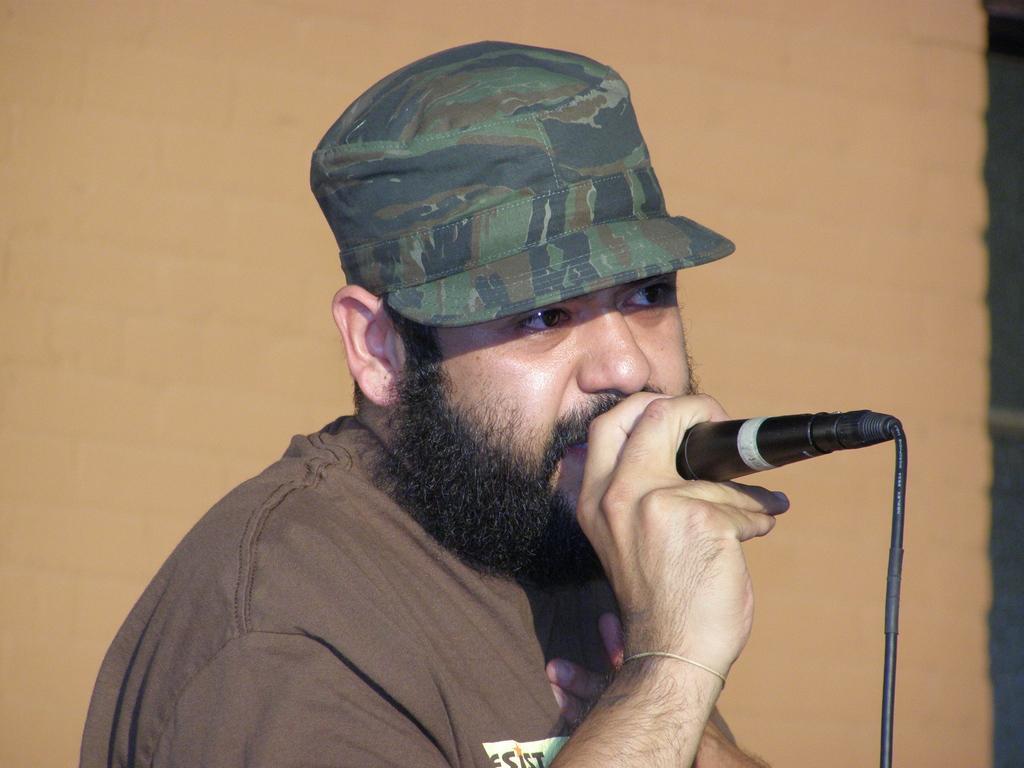In one or two sentences, can you explain what this image depicts? In this image I see a man who is wearing a brown t-shirt and he is also wearing a cap on his head, I can also see he is holding a mic. 